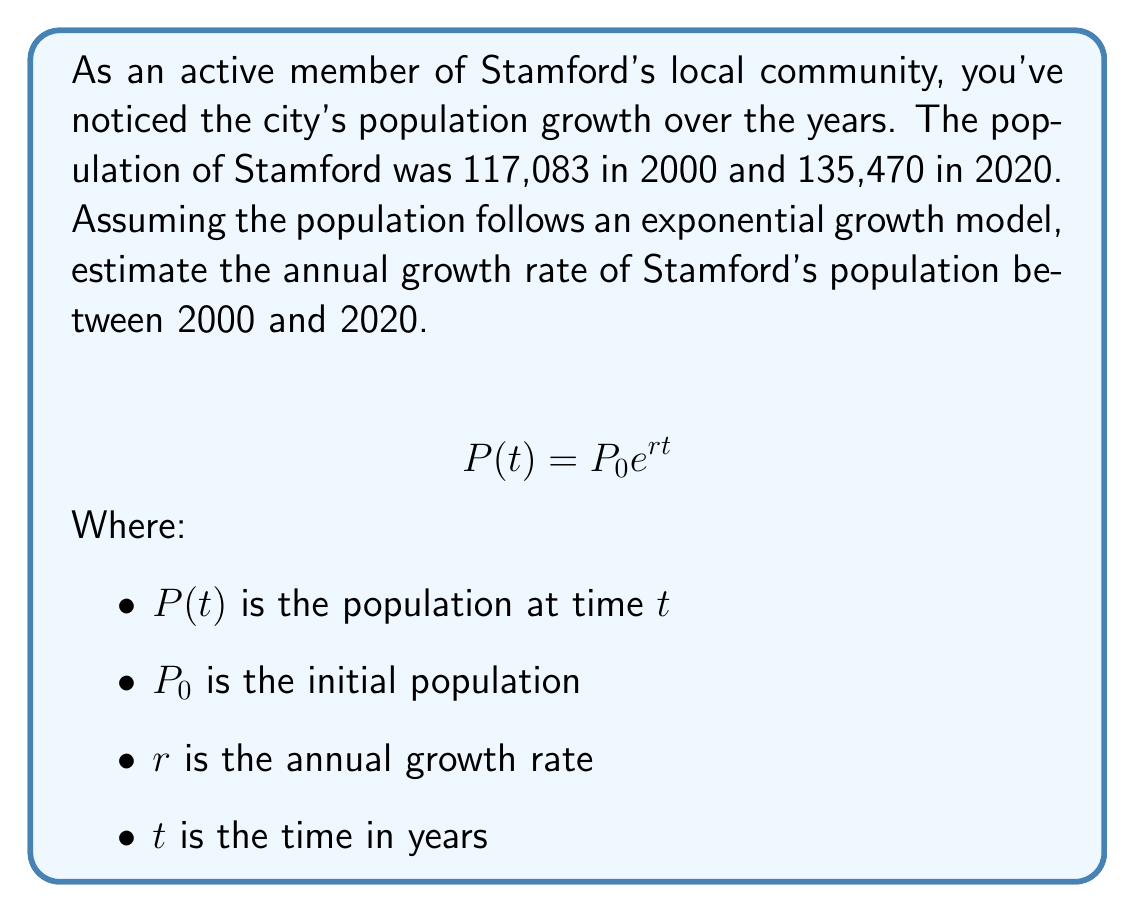Solve this math problem. To solve this problem, we'll use the exponential growth model and the given data:

1. Set up the equation:
   $$135,470 = 117,083 \cdot e^{r \cdot 20}$$

2. Divide both sides by 117,083:
   $$\frac{135,470}{117,083} = e^{r \cdot 20}$$

3. Take the natural logarithm of both sides:
   $$\ln\left(\frac{135,470}{117,083}\right) = r \cdot 20$$

4. Solve for $r$:
   $$r = \frac{\ln\left(\frac{135,470}{117,083}\right)}{20}$$

5. Calculate the value:
   $$r = \frac{\ln(1.1571)}{20} = \frac{0.1459}{20} = 0.007295$$

6. Convert to a percentage:
   $$r \approx 0.7295\%$$

Therefore, the estimated annual growth rate of Stamford's population between 2000 and 2020 is approximately 0.7295%.
Answer: 0.7295% per year 